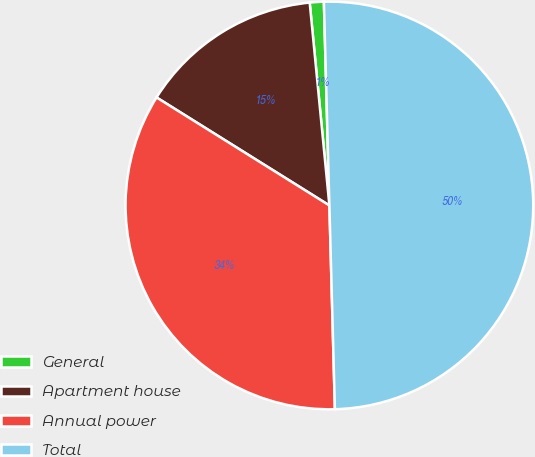<chart> <loc_0><loc_0><loc_500><loc_500><pie_chart><fcel>General<fcel>Apartment house<fcel>Annual power<fcel>Total<nl><fcel>1.11%<fcel>14.57%<fcel>34.32%<fcel>50.0%<nl></chart> 